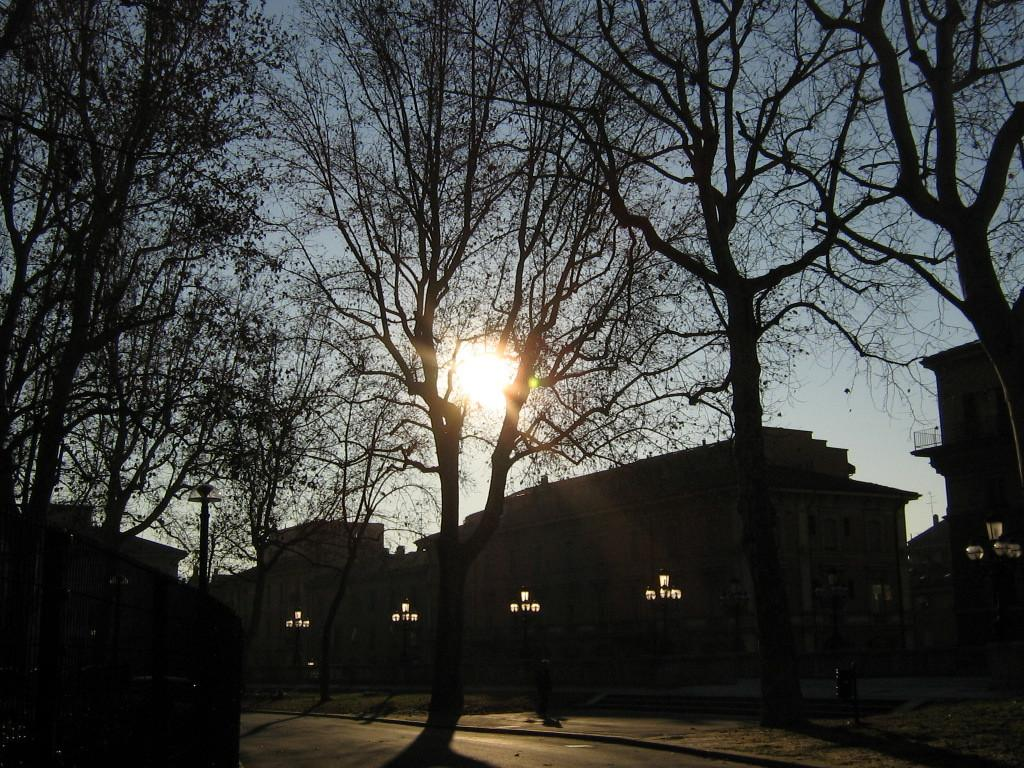What type of structures can be seen in the background of the image? There are buildings in the background of the image. What type of vegetation is present at the bottom of the image? There are trees at the bottom of the image. What celestial body is visible at the top of the image? The sun is visible at the top of the image. Is there a trail of gold leading to the trees at the bottom of the image? There is no trail of gold present in the image; it features buildings, trees, and the sun. What type of nerve is visible in the image? There is no nerve visible in the image; it features buildings, trees, and the sun. 